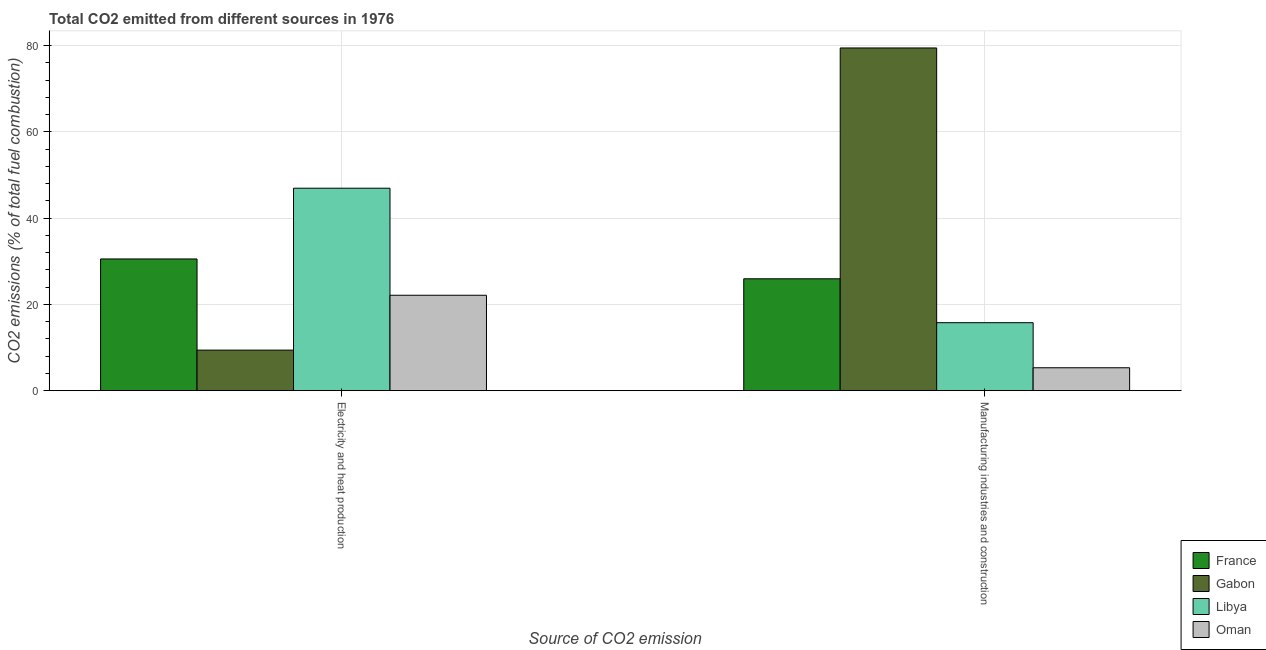How many different coloured bars are there?
Keep it short and to the point. 4. How many bars are there on the 1st tick from the left?
Your answer should be compact. 4. What is the label of the 1st group of bars from the left?
Offer a very short reply. Electricity and heat production. What is the co2 emissions due to electricity and heat production in Gabon?
Your response must be concise. 9.4. Across all countries, what is the maximum co2 emissions due to manufacturing industries?
Give a very brief answer. 79.49. Across all countries, what is the minimum co2 emissions due to manufacturing industries?
Your response must be concise. 5.31. In which country was the co2 emissions due to manufacturing industries maximum?
Your answer should be very brief. Gabon. In which country was the co2 emissions due to manufacturing industries minimum?
Keep it short and to the point. Oman. What is the total co2 emissions due to manufacturing industries in the graph?
Offer a very short reply. 126.5. What is the difference between the co2 emissions due to manufacturing industries in Libya and that in Gabon?
Your answer should be very brief. -63.73. What is the difference between the co2 emissions due to electricity and heat production in Gabon and the co2 emissions due to manufacturing industries in France?
Your answer should be compact. -16.54. What is the average co2 emissions due to electricity and heat production per country?
Keep it short and to the point. 27.26. What is the difference between the co2 emissions due to manufacturing industries and co2 emissions due to electricity and heat production in Libya?
Provide a succinct answer. -31.2. What is the ratio of the co2 emissions due to electricity and heat production in Libya to that in France?
Offer a very short reply. 1.54. Is the co2 emissions due to electricity and heat production in France less than that in Oman?
Your response must be concise. No. In how many countries, is the co2 emissions due to manufacturing industries greater than the average co2 emissions due to manufacturing industries taken over all countries?
Provide a short and direct response. 1. What does the 3rd bar from the right in Manufacturing industries and construction represents?
Offer a terse response. Gabon. How many bars are there?
Provide a succinct answer. 8. Are all the bars in the graph horizontal?
Keep it short and to the point. No. What is the difference between two consecutive major ticks on the Y-axis?
Provide a succinct answer. 20. Does the graph contain grids?
Make the answer very short. Yes. What is the title of the graph?
Offer a terse response. Total CO2 emitted from different sources in 1976. What is the label or title of the X-axis?
Provide a succinct answer. Source of CO2 emission. What is the label or title of the Y-axis?
Ensure brevity in your answer.  CO2 emissions (% of total fuel combustion). What is the CO2 emissions (% of total fuel combustion) in France in Electricity and heat production?
Ensure brevity in your answer.  30.55. What is the CO2 emissions (% of total fuel combustion) in Gabon in Electricity and heat production?
Your answer should be compact. 9.4. What is the CO2 emissions (% of total fuel combustion) of Libya in Electricity and heat production?
Ensure brevity in your answer.  46.96. What is the CO2 emissions (% of total fuel combustion) in Oman in Electricity and heat production?
Your response must be concise. 22.12. What is the CO2 emissions (% of total fuel combustion) of France in Manufacturing industries and construction?
Give a very brief answer. 25.95. What is the CO2 emissions (% of total fuel combustion) in Gabon in Manufacturing industries and construction?
Provide a short and direct response. 79.49. What is the CO2 emissions (% of total fuel combustion) of Libya in Manufacturing industries and construction?
Your response must be concise. 15.76. What is the CO2 emissions (% of total fuel combustion) of Oman in Manufacturing industries and construction?
Keep it short and to the point. 5.31. Across all Source of CO2 emission, what is the maximum CO2 emissions (% of total fuel combustion) of France?
Give a very brief answer. 30.55. Across all Source of CO2 emission, what is the maximum CO2 emissions (% of total fuel combustion) in Gabon?
Offer a very short reply. 79.49. Across all Source of CO2 emission, what is the maximum CO2 emissions (% of total fuel combustion) in Libya?
Your response must be concise. 46.96. Across all Source of CO2 emission, what is the maximum CO2 emissions (% of total fuel combustion) of Oman?
Provide a succinct answer. 22.12. Across all Source of CO2 emission, what is the minimum CO2 emissions (% of total fuel combustion) in France?
Give a very brief answer. 25.95. Across all Source of CO2 emission, what is the minimum CO2 emissions (% of total fuel combustion) of Gabon?
Provide a succinct answer. 9.4. Across all Source of CO2 emission, what is the minimum CO2 emissions (% of total fuel combustion) in Libya?
Make the answer very short. 15.76. Across all Source of CO2 emission, what is the minimum CO2 emissions (% of total fuel combustion) in Oman?
Your response must be concise. 5.31. What is the total CO2 emissions (% of total fuel combustion) in France in the graph?
Offer a very short reply. 56.49. What is the total CO2 emissions (% of total fuel combustion) of Gabon in the graph?
Provide a short and direct response. 88.89. What is the total CO2 emissions (% of total fuel combustion) of Libya in the graph?
Make the answer very short. 62.72. What is the total CO2 emissions (% of total fuel combustion) of Oman in the graph?
Your response must be concise. 27.43. What is the difference between the CO2 emissions (% of total fuel combustion) of France in Electricity and heat production and that in Manufacturing industries and construction?
Make the answer very short. 4.6. What is the difference between the CO2 emissions (% of total fuel combustion) of Gabon in Electricity and heat production and that in Manufacturing industries and construction?
Ensure brevity in your answer.  -70.09. What is the difference between the CO2 emissions (% of total fuel combustion) in Libya in Electricity and heat production and that in Manufacturing industries and construction?
Provide a short and direct response. 31.2. What is the difference between the CO2 emissions (% of total fuel combustion) of Oman in Electricity and heat production and that in Manufacturing industries and construction?
Provide a succinct answer. 16.81. What is the difference between the CO2 emissions (% of total fuel combustion) in France in Electricity and heat production and the CO2 emissions (% of total fuel combustion) in Gabon in Manufacturing industries and construction?
Ensure brevity in your answer.  -48.94. What is the difference between the CO2 emissions (% of total fuel combustion) in France in Electricity and heat production and the CO2 emissions (% of total fuel combustion) in Libya in Manufacturing industries and construction?
Offer a terse response. 14.78. What is the difference between the CO2 emissions (% of total fuel combustion) of France in Electricity and heat production and the CO2 emissions (% of total fuel combustion) of Oman in Manufacturing industries and construction?
Your response must be concise. 25.24. What is the difference between the CO2 emissions (% of total fuel combustion) of Gabon in Electricity and heat production and the CO2 emissions (% of total fuel combustion) of Libya in Manufacturing industries and construction?
Give a very brief answer. -6.36. What is the difference between the CO2 emissions (% of total fuel combustion) of Gabon in Electricity and heat production and the CO2 emissions (% of total fuel combustion) of Oman in Manufacturing industries and construction?
Keep it short and to the point. 4.09. What is the difference between the CO2 emissions (% of total fuel combustion) of Libya in Electricity and heat production and the CO2 emissions (% of total fuel combustion) of Oman in Manufacturing industries and construction?
Your response must be concise. 41.65. What is the average CO2 emissions (% of total fuel combustion) in France per Source of CO2 emission?
Your response must be concise. 28.25. What is the average CO2 emissions (% of total fuel combustion) of Gabon per Source of CO2 emission?
Provide a succinct answer. 44.44. What is the average CO2 emissions (% of total fuel combustion) in Libya per Source of CO2 emission?
Offer a terse response. 31.36. What is the average CO2 emissions (% of total fuel combustion) of Oman per Source of CO2 emission?
Provide a succinct answer. 13.72. What is the difference between the CO2 emissions (% of total fuel combustion) in France and CO2 emissions (% of total fuel combustion) in Gabon in Electricity and heat production?
Your answer should be very brief. 21.14. What is the difference between the CO2 emissions (% of total fuel combustion) in France and CO2 emissions (% of total fuel combustion) in Libya in Electricity and heat production?
Offer a very short reply. -16.41. What is the difference between the CO2 emissions (% of total fuel combustion) in France and CO2 emissions (% of total fuel combustion) in Oman in Electricity and heat production?
Keep it short and to the point. 8.42. What is the difference between the CO2 emissions (% of total fuel combustion) in Gabon and CO2 emissions (% of total fuel combustion) in Libya in Electricity and heat production?
Ensure brevity in your answer.  -37.55. What is the difference between the CO2 emissions (% of total fuel combustion) in Gabon and CO2 emissions (% of total fuel combustion) in Oman in Electricity and heat production?
Ensure brevity in your answer.  -12.72. What is the difference between the CO2 emissions (% of total fuel combustion) in Libya and CO2 emissions (% of total fuel combustion) in Oman in Electricity and heat production?
Provide a succinct answer. 24.83. What is the difference between the CO2 emissions (% of total fuel combustion) of France and CO2 emissions (% of total fuel combustion) of Gabon in Manufacturing industries and construction?
Keep it short and to the point. -53.54. What is the difference between the CO2 emissions (% of total fuel combustion) of France and CO2 emissions (% of total fuel combustion) of Libya in Manufacturing industries and construction?
Your answer should be very brief. 10.18. What is the difference between the CO2 emissions (% of total fuel combustion) of France and CO2 emissions (% of total fuel combustion) of Oman in Manufacturing industries and construction?
Offer a very short reply. 20.64. What is the difference between the CO2 emissions (% of total fuel combustion) in Gabon and CO2 emissions (% of total fuel combustion) in Libya in Manufacturing industries and construction?
Offer a very short reply. 63.73. What is the difference between the CO2 emissions (% of total fuel combustion) in Gabon and CO2 emissions (% of total fuel combustion) in Oman in Manufacturing industries and construction?
Offer a very short reply. 74.18. What is the difference between the CO2 emissions (% of total fuel combustion) in Libya and CO2 emissions (% of total fuel combustion) in Oman in Manufacturing industries and construction?
Provide a succinct answer. 10.45. What is the ratio of the CO2 emissions (% of total fuel combustion) in France in Electricity and heat production to that in Manufacturing industries and construction?
Give a very brief answer. 1.18. What is the ratio of the CO2 emissions (% of total fuel combustion) in Gabon in Electricity and heat production to that in Manufacturing industries and construction?
Offer a terse response. 0.12. What is the ratio of the CO2 emissions (% of total fuel combustion) in Libya in Electricity and heat production to that in Manufacturing industries and construction?
Your response must be concise. 2.98. What is the ratio of the CO2 emissions (% of total fuel combustion) of Oman in Electricity and heat production to that in Manufacturing industries and construction?
Offer a very short reply. 4.17. What is the difference between the highest and the second highest CO2 emissions (% of total fuel combustion) of France?
Offer a terse response. 4.6. What is the difference between the highest and the second highest CO2 emissions (% of total fuel combustion) in Gabon?
Make the answer very short. 70.09. What is the difference between the highest and the second highest CO2 emissions (% of total fuel combustion) in Libya?
Keep it short and to the point. 31.2. What is the difference between the highest and the second highest CO2 emissions (% of total fuel combustion) in Oman?
Your answer should be compact. 16.81. What is the difference between the highest and the lowest CO2 emissions (% of total fuel combustion) in France?
Offer a terse response. 4.6. What is the difference between the highest and the lowest CO2 emissions (% of total fuel combustion) of Gabon?
Provide a short and direct response. 70.09. What is the difference between the highest and the lowest CO2 emissions (% of total fuel combustion) in Libya?
Give a very brief answer. 31.2. What is the difference between the highest and the lowest CO2 emissions (% of total fuel combustion) of Oman?
Give a very brief answer. 16.81. 